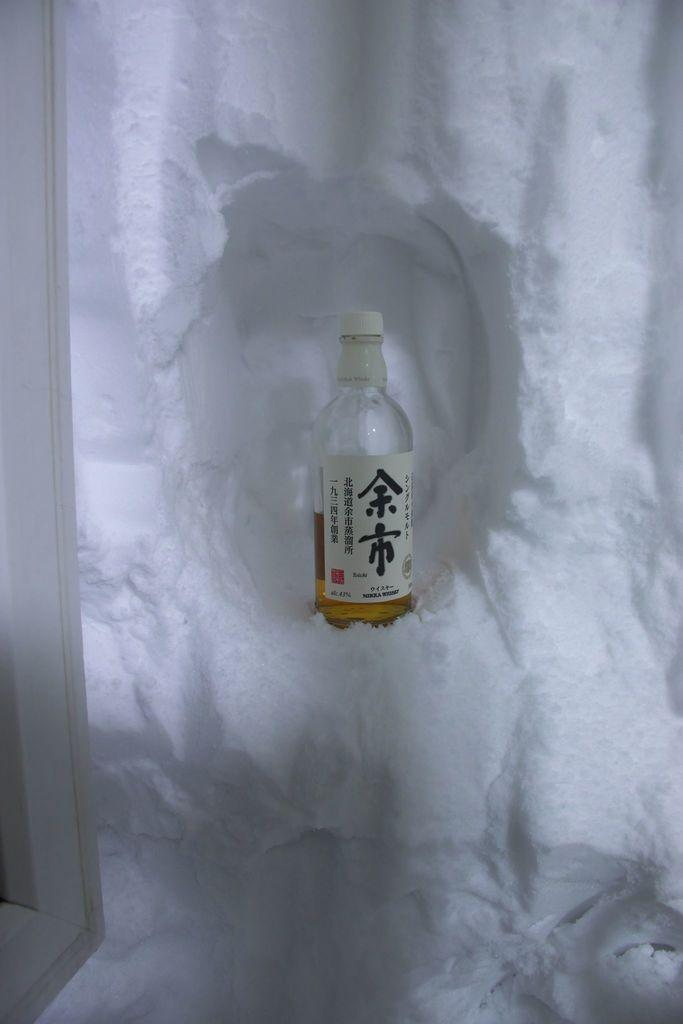What is present in the image that is used for holding liquids? There is a bottle in the image that is used for holding liquids. How is the bottle being kept cool in the image? The bottle is surrounded by ice in the image. What color is the bottle lid? The bottle lid is white. What color is the label on the bottle? The label on the bottle is white. What color is the text on the label? Something is written on the label in black color. How many quarters can be seen in the image? There are no quarters present in the image. What type of glass is used to make the bottle in the image? The facts provided do not mention the type of glass used to make the bottle. 